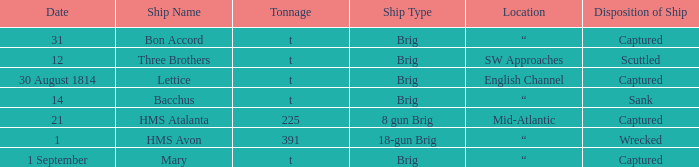With a tonnage of 225 what is the ship type? 8 gun Brig. Parse the table in full. {'header': ['Date', 'Ship Name', 'Tonnage', 'Ship Type', 'Location', 'Disposition of Ship'], 'rows': [['31', 'Bon Accord', 't', 'Brig', '“', 'Captured'], ['12', 'Three Brothers', 't', 'Brig', 'SW Approaches', 'Scuttled'], ['30 August 1814', 'Lettice', 't', 'Brig', 'English Channel', 'Captured'], ['14', 'Bacchus', 't', 'Brig', '“', 'Sank'], ['21', 'HMS Atalanta', '225', '8 gun Brig', 'Mid-Atlantic', 'Captured'], ['1', 'HMS Avon', '391', '18-gun Brig', '“', 'Wrecked'], ['1 September', 'Mary', 't', 'Brig', '“', 'Captured']]} 